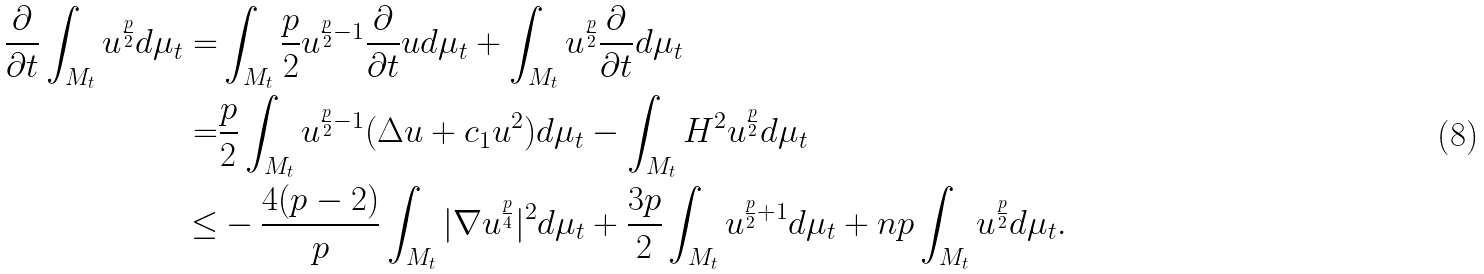Convert formula to latex. <formula><loc_0><loc_0><loc_500><loc_500>\frac { \partial } { \partial t } \int _ { M _ { t } } u ^ { \frac { p } { 2 } } d \mu _ { t } = & \int _ { M _ { t } } \frac { p } { 2 } u ^ { \frac { p } { 2 } - 1 } \frac { \partial } { \partial t } u d \mu _ { t } + \int _ { M _ { t } } u ^ { \frac { p } { 2 } } \frac { \partial } { \partial t } d \mu _ { t } \\ = & \frac { p } { 2 } \int _ { M _ { t } } u ^ { \frac { p } { 2 } - 1 } ( \Delta u + c _ { 1 } u ^ { 2 } ) d \mu _ { t } - \int _ { M _ { t } } H ^ { 2 } u ^ { \frac { p } { 2 } } d \mu _ { t } \\ \leq & - \frac { 4 ( p - 2 ) } { p } \int _ { M _ { t } } | \nabla u ^ { \frac { p } { 4 } } | ^ { 2 } d \mu _ { t } + \frac { 3 p } { 2 } \int _ { M _ { t } } u ^ { \frac { p } { 2 } + 1 } d \mu _ { t } + n p \int _ { M _ { t } } u ^ { \frac { p } { 2 } } d \mu _ { t } .</formula> 